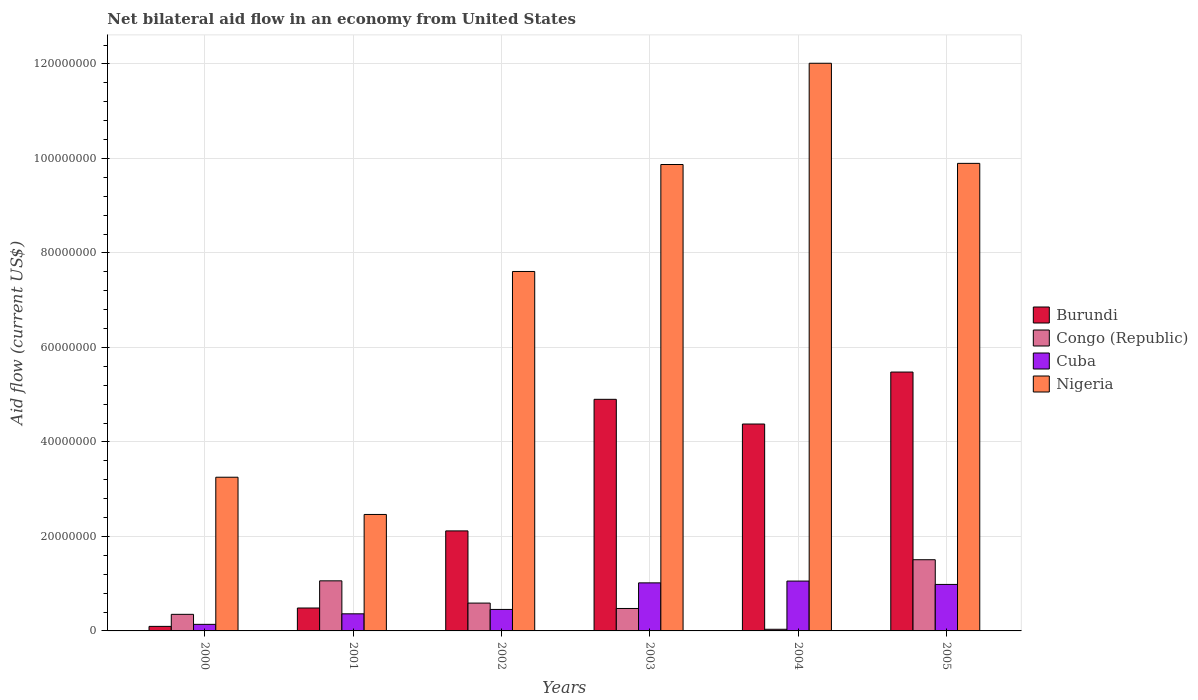Are the number of bars on each tick of the X-axis equal?
Your response must be concise. Yes. In how many cases, is the number of bars for a given year not equal to the number of legend labels?
Your answer should be compact. 0. What is the net bilateral aid flow in Congo (Republic) in 2003?
Ensure brevity in your answer.  4.75e+06. Across all years, what is the maximum net bilateral aid flow in Nigeria?
Give a very brief answer. 1.20e+08. In which year was the net bilateral aid flow in Nigeria maximum?
Provide a short and direct response. 2004. In which year was the net bilateral aid flow in Congo (Republic) minimum?
Offer a very short reply. 2004. What is the total net bilateral aid flow in Nigeria in the graph?
Your answer should be very brief. 4.51e+08. What is the difference between the net bilateral aid flow in Congo (Republic) in 2001 and that in 2004?
Ensure brevity in your answer.  1.02e+07. What is the difference between the net bilateral aid flow in Nigeria in 2000 and the net bilateral aid flow in Congo (Republic) in 2003?
Make the answer very short. 2.78e+07. What is the average net bilateral aid flow in Burundi per year?
Make the answer very short. 2.91e+07. In the year 2000, what is the difference between the net bilateral aid flow in Congo (Republic) and net bilateral aid flow in Nigeria?
Offer a very short reply. -2.90e+07. In how many years, is the net bilateral aid flow in Cuba greater than 8000000 US$?
Provide a succinct answer. 3. What is the ratio of the net bilateral aid flow in Burundi in 2000 to that in 2002?
Keep it short and to the point. 0.05. What is the difference between the highest and the second highest net bilateral aid flow in Cuba?
Give a very brief answer. 3.80e+05. What is the difference between the highest and the lowest net bilateral aid flow in Congo (Republic)?
Offer a terse response. 1.47e+07. Is it the case that in every year, the sum of the net bilateral aid flow in Cuba and net bilateral aid flow in Congo (Republic) is greater than the sum of net bilateral aid flow in Burundi and net bilateral aid flow in Nigeria?
Your response must be concise. No. What does the 3rd bar from the left in 2002 represents?
Ensure brevity in your answer.  Cuba. What does the 4th bar from the right in 2002 represents?
Ensure brevity in your answer.  Burundi. Is it the case that in every year, the sum of the net bilateral aid flow in Cuba and net bilateral aid flow in Congo (Republic) is greater than the net bilateral aid flow in Burundi?
Provide a short and direct response. No. Are all the bars in the graph horizontal?
Offer a very short reply. No. How many years are there in the graph?
Your response must be concise. 6. What is the difference between two consecutive major ticks on the Y-axis?
Offer a terse response. 2.00e+07. Are the values on the major ticks of Y-axis written in scientific E-notation?
Your answer should be compact. No. How are the legend labels stacked?
Provide a short and direct response. Vertical. What is the title of the graph?
Your answer should be compact. Net bilateral aid flow in an economy from United States. Does "Madagascar" appear as one of the legend labels in the graph?
Provide a succinct answer. No. What is the label or title of the X-axis?
Your answer should be very brief. Years. What is the label or title of the Y-axis?
Keep it short and to the point. Aid flow (current US$). What is the Aid flow (current US$) of Burundi in 2000?
Your answer should be compact. 9.60e+05. What is the Aid flow (current US$) of Congo (Republic) in 2000?
Offer a terse response. 3.51e+06. What is the Aid flow (current US$) of Cuba in 2000?
Give a very brief answer. 1.39e+06. What is the Aid flow (current US$) of Nigeria in 2000?
Offer a very short reply. 3.25e+07. What is the Aid flow (current US$) in Burundi in 2001?
Your response must be concise. 4.85e+06. What is the Aid flow (current US$) in Congo (Republic) in 2001?
Give a very brief answer. 1.06e+07. What is the Aid flow (current US$) in Cuba in 2001?
Offer a terse response. 3.62e+06. What is the Aid flow (current US$) in Nigeria in 2001?
Keep it short and to the point. 2.46e+07. What is the Aid flow (current US$) in Burundi in 2002?
Offer a very short reply. 2.12e+07. What is the Aid flow (current US$) in Congo (Republic) in 2002?
Provide a short and direct response. 5.89e+06. What is the Aid flow (current US$) in Cuba in 2002?
Your answer should be very brief. 4.55e+06. What is the Aid flow (current US$) in Nigeria in 2002?
Keep it short and to the point. 7.61e+07. What is the Aid flow (current US$) in Burundi in 2003?
Offer a very short reply. 4.90e+07. What is the Aid flow (current US$) in Congo (Republic) in 2003?
Your answer should be compact. 4.75e+06. What is the Aid flow (current US$) in Cuba in 2003?
Keep it short and to the point. 1.02e+07. What is the Aid flow (current US$) in Nigeria in 2003?
Provide a succinct answer. 9.87e+07. What is the Aid flow (current US$) in Burundi in 2004?
Offer a very short reply. 4.38e+07. What is the Aid flow (current US$) of Cuba in 2004?
Keep it short and to the point. 1.06e+07. What is the Aid flow (current US$) in Nigeria in 2004?
Your response must be concise. 1.20e+08. What is the Aid flow (current US$) of Burundi in 2005?
Give a very brief answer. 5.48e+07. What is the Aid flow (current US$) of Congo (Republic) in 2005?
Offer a terse response. 1.51e+07. What is the Aid flow (current US$) of Cuba in 2005?
Offer a very short reply. 9.84e+06. What is the Aid flow (current US$) in Nigeria in 2005?
Your answer should be very brief. 9.90e+07. Across all years, what is the maximum Aid flow (current US$) of Burundi?
Offer a very short reply. 5.48e+07. Across all years, what is the maximum Aid flow (current US$) of Congo (Republic)?
Give a very brief answer. 1.51e+07. Across all years, what is the maximum Aid flow (current US$) of Cuba?
Provide a short and direct response. 1.06e+07. Across all years, what is the maximum Aid flow (current US$) in Nigeria?
Make the answer very short. 1.20e+08. Across all years, what is the minimum Aid flow (current US$) in Burundi?
Offer a very short reply. 9.60e+05. Across all years, what is the minimum Aid flow (current US$) in Cuba?
Your response must be concise. 1.39e+06. Across all years, what is the minimum Aid flow (current US$) of Nigeria?
Provide a short and direct response. 2.46e+07. What is the total Aid flow (current US$) of Burundi in the graph?
Give a very brief answer. 1.75e+08. What is the total Aid flow (current US$) in Congo (Republic) in the graph?
Provide a short and direct response. 4.02e+07. What is the total Aid flow (current US$) in Cuba in the graph?
Your response must be concise. 4.01e+07. What is the total Aid flow (current US$) in Nigeria in the graph?
Provide a short and direct response. 4.51e+08. What is the difference between the Aid flow (current US$) of Burundi in 2000 and that in 2001?
Provide a short and direct response. -3.89e+06. What is the difference between the Aid flow (current US$) in Congo (Republic) in 2000 and that in 2001?
Give a very brief answer. -7.09e+06. What is the difference between the Aid flow (current US$) of Cuba in 2000 and that in 2001?
Provide a succinct answer. -2.23e+06. What is the difference between the Aid flow (current US$) of Nigeria in 2000 and that in 2001?
Make the answer very short. 7.88e+06. What is the difference between the Aid flow (current US$) in Burundi in 2000 and that in 2002?
Provide a succinct answer. -2.02e+07. What is the difference between the Aid flow (current US$) in Congo (Republic) in 2000 and that in 2002?
Your response must be concise. -2.38e+06. What is the difference between the Aid flow (current US$) of Cuba in 2000 and that in 2002?
Offer a terse response. -3.16e+06. What is the difference between the Aid flow (current US$) in Nigeria in 2000 and that in 2002?
Keep it short and to the point. -4.36e+07. What is the difference between the Aid flow (current US$) of Burundi in 2000 and that in 2003?
Provide a succinct answer. -4.81e+07. What is the difference between the Aid flow (current US$) of Congo (Republic) in 2000 and that in 2003?
Keep it short and to the point. -1.24e+06. What is the difference between the Aid flow (current US$) in Cuba in 2000 and that in 2003?
Ensure brevity in your answer.  -8.78e+06. What is the difference between the Aid flow (current US$) of Nigeria in 2000 and that in 2003?
Give a very brief answer. -6.62e+07. What is the difference between the Aid flow (current US$) in Burundi in 2000 and that in 2004?
Keep it short and to the point. -4.28e+07. What is the difference between the Aid flow (current US$) in Congo (Republic) in 2000 and that in 2004?
Your answer should be very brief. 3.16e+06. What is the difference between the Aid flow (current US$) in Cuba in 2000 and that in 2004?
Give a very brief answer. -9.16e+06. What is the difference between the Aid flow (current US$) of Nigeria in 2000 and that in 2004?
Make the answer very short. -8.76e+07. What is the difference between the Aid flow (current US$) in Burundi in 2000 and that in 2005?
Provide a succinct answer. -5.38e+07. What is the difference between the Aid flow (current US$) of Congo (Republic) in 2000 and that in 2005?
Your response must be concise. -1.16e+07. What is the difference between the Aid flow (current US$) in Cuba in 2000 and that in 2005?
Provide a succinct answer. -8.45e+06. What is the difference between the Aid flow (current US$) in Nigeria in 2000 and that in 2005?
Give a very brief answer. -6.64e+07. What is the difference between the Aid flow (current US$) of Burundi in 2001 and that in 2002?
Offer a terse response. -1.63e+07. What is the difference between the Aid flow (current US$) of Congo (Republic) in 2001 and that in 2002?
Give a very brief answer. 4.71e+06. What is the difference between the Aid flow (current US$) of Cuba in 2001 and that in 2002?
Your response must be concise. -9.30e+05. What is the difference between the Aid flow (current US$) in Nigeria in 2001 and that in 2002?
Offer a very short reply. -5.14e+07. What is the difference between the Aid flow (current US$) of Burundi in 2001 and that in 2003?
Give a very brief answer. -4.42e+07. What is the difference between the Aid flow (current US$) in Congo (Republic) in 2001 and that in 2003?
Your response must be concise. 5.85e+06. What is the difference between the Aid flow (current US$) of Cuba in 2001 and that in 2003?
Your answer should be very brief. -6.55e+06. What is the difference between the Aid flow (current US$) in Nigeria in 2001 and that in 2003?
Provide a short and direct response. -7.41e+07. What is the difference between the Aid flow (current US$) in Burundi in 2001 and that in 2004?
Give a very brief answer. -3.89e+07. What is the difference between the Aid flow (current US$) of Congo (Republic) in 2001 and that in 2004?
Make the answer very short. 1.02e+07. What is the difference between the Aid flow (current US$) in Cuba in 2001 and that in 2004?
Offer a very short reply. -6.93e+06. What is the difference between the Aid flow (current US$) of Nigeria in 2001 and that in 2004?
Give a very brief answer. -9.55e+07. What is the difference between the Aid flow (current US$) in Burundi in 2001 and that in 2005?
Your response must be concise. -4.99e+07. What is the difference between the Aid flow (current US$) in Congo (Republic) in 2001 and that in 2005?
Offer a terse response. -4.47e+06. What is the difference between the Aid flow (current US$) in Cuba in 2001 and that in 2005?
Provide a short and direct response. -6.22e+06. What is the difference between the Aid flow (current US$) in Nigeria in 2001 and that in 2005?
Keep it short and to the point. -7.43e+07. What is the difference between the Aid flow (current US$) of Burundi in 2002 and that in 2003?
Provide a short and direct response. -2.78e+07. What is the difference between the Aid flow (current US$) of Congo (Republic) in 2002 and that in 2003?
Your answer should be compact. 1.14e+06. What is the difference between the Aid flow (current US$) of Cuba in 2002 and that in 2003?
Keep it short and to the point. -5.62e+06. What is the difference between the Aid flow (current US$) of Nigeria in 2002 and that in 2003?
Make the answer very short. -2.26e+07. What is the difference between the Aid flow (current US$) of Burundi in 2002 and that in 2004?
Provide a succinct answer. -2.26e+07. What is the difference between the Aid flow (current US$) in Congo (Republic) in 2002 and that in 2004?
Provide a short and direct response. 5.54e+06. What is the difference between the Aid flow (current US$) in Cuba in 2002 and that in 2004?
Your answer should be very brief. -6.00e+06. What is the difference between the Aid flow (current US$) of Nigeria in 2002 and that in 2004?
Your response must be concise. -4.41e+07. What is the difference between the Aid flow (current US$) in Burundi in 2002 and that in 2005?
Provide a succinct answer. -3.36e+07. What is the difference between the Aid flow (current US$) of Congo (Republic) in 2002 and that in 2005?
Give a very brief answer. -9.18e+06. What is the difference between the Aid flow (current US$) of Cuba in 2002 and that in 2005?
Provide a short and direct response. -5.29e+06. What is the difference between the Aid flow (current US$) in Nigeria in 2002 and that in 2005?
Your answer should be compact. -2.29e+07. What is the difference between the Aid flow (current US$) of Burundi in 2003 and that in 2004?
Your response must be concise. 5.23e+06. What is the difference between the Aid flow (current US$) in Congo (Republic) in 2003 and that in 2004?
Keep it short and to the point. 4.40e+06. What is the difference between the Aid flow (current US$) in Cuba in 2003 and that in 2004?
Your answer should be compact. -3.80e+05. What is the difference between the Aid flow (current US$) of Nigeria in 2003 and that in 2004?
Keep it short and to the point. -2.14e+07. What is the difference between the Aid flow (current US$) in Burundi in 2003 and that in 2005?
Keep it short and to the point. -5.77e+06. What is the difference between the Aid flow (current US$) in Congo (Republic) in 2003 and that in 2005?
Your answer should be very brief. -1.03e+07. What is the difference between the Aid flow (current US$) in Nigeria in 2003 and that in 2005?
Offer a very short reply. -2.40e+05. What is the difference between the Aid flow (current US$) in Burundi in 2004 and that in 2005?
Give a very brief answer. -1.10e+07. What is the difference between the Aid flow (current US$) of Congo (Republic) in 2004 and that in 2005?
Your answer should be compact. -1.47e+07. What is the difference between the Aid flow (current US$) in Cuba in 2004 and that in 2005?
Offer a very short reply. 7.10e+05. What is the difference between the Aid flow (current US$) of Nigeria in 2004 and that in 2005?
Your answer should be compact. 2.12e+07. What is the difference between the Aid flow (current US$) of Burundi in 2000 and the Aid flow (current US$) of Congo (Republic) in 2001?
Offer a very short reply. -9.64e+06. What is the difference between the Aid flow (current US$) in Burundi in 2000 and the Aid flow (current US$) in Cuba in 2001?
Give a very brief answer. -2.66e+06. What is the difference between the Aid flow (current US$) of Burundi in 2000 and the Aid flow (current US$) of Nigeria in 2001?
Make the answer very short. -2.37e+07. What is the difference between the Aid flow (current US$) of Congo (Republic) in 2000 and the Aid flow (current US$) of Nigeria in 2001?
Make the answer very short. -2.11e+07. What is the difference between the Aid flow (current US$) of Cuba in 2000 and the Aid flow (current US$) of Nigeria in 2001?
Provide a succinct answer. -2.33e+07. What is the difference between the Aid flow (current US$) of Burundi in 2000 and the Aid flow (current US$) of Congo (Republic) in 2002?
Your answer should be very brief. -4.93e+06. What is the difference between the Aid flow (current US$) in Burundi in 2000 and the Aid flow (current US$) in Cuba in 2002?
Provide a short and direct response. -3.59e+06. What is the difference between the Aid flow (current US$) in Burundi in 2000 and the Aid flow (current US$) in Nigeria in 2002?
Give a very brief answer. -7.51e+07. What is the difference between the Aid flow (current US$) of Congo (Republic) in 2000 and the Aid flow (current US$) of Cuba in 2002?
Your response must be concise. -1.04e+06. What is the difference between the Aid flow (current US$) in Congo (Republic) in 2000 and the Aid flow (current US$) in Nigeria in 2002?
Make the answer very short. -7.26e+07. What is the difference between the Aid flow (current US$) in Cuba in 2000 and the Aid flow (current US$) in Nigeria in 2002?
Keep it short and to the point. -7.47e+07. What is the difference between the Aid flow (current US$) in Burundi in 2000 and the Aid flow (current US$) in Congo (Republic) in 2003?
Keep it short and to the point. -3.79e+06. What is the difference between the Aid flow (current US$) of Burundi in 2000 and the Aid flow (current US$) of Cuba in 2003?
Your answer should be compact. -9.21e+06. What is the difference between the Aid flow (current US$) of Burundi in 2000 and the Aid flow (current US$) of Nigeria in 2003?
Provide a short and direct response. -9.78e+07. What is the difference between the Aid flow (current US$) in Congo (Republic) in 2000 and the Aid flow (current US$) in Cuba in 2003?
Your answer should be very brief. -6.66e+06. What is the difference between the Aid flow (current US$) in Congo (Republic) in 2000 and the Aid flow (current US$) in Nigeria in 2003?
Your answer should be very brief. -9.52e+07. What is the difference between the Aid flow (current US$) in Cuba in 2000 and the Aid flow (current US$) in Nigeria in 2003?
Offer a terse response. -9.73e+07. What is the difference between the Aid flow (current US$) of Burundi in 2000 and the Aid flow (current US$) of Cuba in 2004?
Your response must be concise. -9.59e+06. What is the difference between the Aid flow (current US$) in Burundi in 2000 and the Aid flow (current US$) in Nigeria in 2004?
Your answer should be very brief. -1.19e+08. What is the difference between the Aid flow (current US$) in Congo (Republic) in 2000 and the Aid flow (current US$) in Cuba in 2004?
Your answer should be very brief. -7.04e+06. What is the difference between the Aid flow (current US$) of Congo (Republic) in 2000 and the Aid flow (current US$) of Nigeria in 2004?
Your answer should be compact. -1.17e+08. What is the difference between the Aid flow (current US$) of Cuba in 2000 and the Aid flow (current US$) of Nigeria in 2004?
Your response must be concise. -1.19e+08. What is the difference between the Aid flow (current US$) in Burundi in 2000 and the Aid flow (current US$) in Congo (Republic) in 2005?
Offer a terse response. -1.41e+07. What is the difference between the Aid flow (current US$) of Burundi in 2000 and the Aid flow (current US$) of Cuba in 2005?
Make the answer very short. -8.88e+06. What is the difference between the Aid flow (current US$) in Burundi in 2000 and the Aid flow (current US$) in Nigeria in 2005?
Make the answer very short. -9.80e+07. What is the difference between the Aid flow (current US$) in Congo (Republic) in 2000 and the Aid flow (current US$) in Cuba in 2005?
Offer a very short reply. -6.33e+06. What is the difference between the Aid flow (current US$) in Congo (Republic) in 2000 and the Aid flow (current US$) in Nigeria in 2005?
Offer a terse response. -9.54e+07. What is the difference between the Aid flow (current US$) of Cuba in 2000 and the Aid flow (current US$) of Nigeria in 2005?
Offer a terse response. -9.76e+07. What is the difference between the Aid flow (current US$) of Burundi in 2001 and the Aid flow (current US$) of Congo (Republic) in 2002?
Offer a terse response. -1.04e+06. What is the difference between the Aid flow (current US$) in Burundi in 2001 and the Aid flow (current US$) in Cuba in 2002?
Offer a very short reply. 3.00e+05. What is the difference between the Aid flow (current US$) in Burundi in 2001 and the Aid flow (current US$) in Nigeria in 2002?
Offer a very short reply. -7.12e+07. What is the difference between the Aid flow (current US$) in Congo (Republic) in 2001 and the Aid flow (current US$) in Cuba in 2002?
Provide a succinct answer. 6.05e+06. What is the difference between the Aid flow (current US$) of Congo (Republic) in 2001 and the Aid flow (current US$) of Nigeria in 2002?
Keep it short and to the point. -6.55e+07. What is the difference between the Aid flow (current US$) of Cuba in 2001 and the Aid flow (current US$) of Nigeria in 2002?
Offer a very short reply. -7.25e+07. What is the difference between the Aid flow (current US$) in Burundi in 2001 and the Aid flow (current US$) in Congo (Republic) in 2003?
Offer a very short reply. 1.00e+05. What is the difference between the Aid flow (current US$) of Burundi in 2001 and the Aid flow (current US$) of Cuba in 2003?
Give a very brief answer. -5.32e+06. What is the difference between the Aid flow (current US$) of Burundi in 2001 and the Aid flow (current US$) of Nigeria in 2003?
Offer a very short reply. -9.39e+07. What is the difference between the Aid flow (current US$) in Congo (Republic) in 2001 and the Aid flow (current US$) in Nigeria in 2003?
Keep it short and to the point. -8.81e+07. What is the difference between the Aid flow (current US$) of Cuba in 2001 and the Aid flow (current US$) of Nigeria in 2003?
Offer a terse response. -9.51e+07. What is the difference between the Aid flow (current US$) of Burundi in 2001 and the Aid flow (current US$) of Congo (Republic) in 2004?
Make the answer very short. 4.50e+06. What is the difference between the Aid flow (current US$) in Burundi in 2001 and the Aid flow (current US$) in Cuba in 2004?
Your response must be concise. -5.70e+06. What is the difference between the Aid flow (current US$) of Burundi in 2001 and the Aid flow (current US$) of Nigeria in 2004?
Provide a short and direct response. -1.15e+08. What is the difference between the Aid flow (current US$) in Congo (Republic) in 2001 and the Aid flow (current US$) in Cuba in 2004?
Offer a very short reply. 5.00e+04. What is the difference between the Aid flow (current US$) of Congo (Republic) in 2001 and the Aid flow (current US$) of Nigeria in 2004?
Provide a short and direct response. -1.10e+08. What is the difference between the Aid flow (current US$) in Cuba in 2001 and the Aid flow (current US$) in Nigeria in 2004?
Your answer should be compact. -1.17e+08. What is the difference between the Aid flow (current US$) of Burundi in 2001 and the Aid flow (current US$) of Congo (Republic) in 2005?
Provide a succinct answer. -1.02e+07. What is the difference between the Aid flow (current US$) in Burundi in 2001 and the Aid flow (current US$) in Cuba in 2005?
Offer a very short reply. -4.99e+06. What is the difference between the Aid flow (current US$) of Burundi in 2001 and the Aid flow (current US$) of Nigeria in 2005?
Provide a short and direct response. -9.41e+07. What is the difference between the Aid flow (current US$) in Congo (Republic) in 2001 and the Aid flow (current US$) in Cuba in 2005?
Your answer should be very brief. 7.60e+05. What is the difference between the Aid flow (current US$) in Congo (Republic) in 2001 and the Aid flow (current US$) in Nigeria in 2005?
Give a very brief answer. -8.84e+07. What is the difference between the Aid flow (current US$) in Cuba in 2001 and the Aid flow (current US$) in Nigeria in 2005?
Keep it short and to the point. -9.53e+07. What is the difference between the Aid flow (current US$) in Burundi in 2002 and the Aid flow (current US$) in Congo (Republic) in 2003?
Offer a very short reply. 1.64e+07. What is the difference between the Aid flow (current US$) in Burundi in 2002 and the Aid flow (current US$) in Cuba in 2003?
Keep it short and to the point. 1.10e+07. What is the difference between the Aid flow (current US$) of Burundi in 2002 and the Aid flow (current US$) of Nigeria in 2003?
Ensure brevity in your answer.  -7.76e+07. What is the difference between the Aid flow (current US$) in Congo (Republic) in 2002 and the Aid flow (current US$) in Cuba in 2003?
Keep it short and to the point. -4.28e+06. What is the difference between the Aid flow (current US$) of Congo (Republic) in 2002 and the Aid flow (current US$) of Nigeria in 2003?
Offer a terse response. -9.28e+07. What is the difference between the Aid flow (current US$) in Cuba in 2002 and the Aid flow (current US$) in Nigeria in 2003?
Provide a short and direct response. -9.42e+07. What is the difference between the Aid flow (current US$) in Burundi in 2002 and the Aid flow (current US$) in Congo (Republic) in 2004?
Offer a terse response. 2.08e+07. What is the difference between the Aid flow (current US$) in Burundi in 2002 and the Aid flow (current US$) in Cuba in 2004?
Provide a short and direct response. 1.06e+07. What is the difference between the Aid flow (current US$) in Burundi in 2002 and the Aid flow (current US$) in Nigeria in 2004?
Offer a very short reply. -9.90e+07. What is the difference between the Aid flow (current US$) of Congo (Republic) in 2002 and the Aid flow (current US$) of Cuba in 2004?
Your answer should be compact. -4.66e+06. What is the difference between the Aid flow (current US$) of Congo (Republic) in 2002 and the Aid flow (current US$) of Nigeria in 2004?
Provide a short and direct response. -1.14e+08. What is the difference between the Aid flow (current US$) in Cuba in 2002 and the Aid flow (current US$) in Nigeria in 2004?
Offer a terse response. -1.16e+08. What is the difference between the Aid flow (current US$) in Burundi in 2002 and the Aid flow (current US$) in Congo (Republic) in 2005?
Provide a short and direct response. 6.10e+06. What is the difference between the Aid flow (current US$) in Burundi in 2002 and the Aid flow (current US$) in Cuba in 2005?
Keep it short and to the point. 1.13e+07. What is the difference between the Aid flow (current US$) of Burundi in 2002 and the Aid flow (current US$) of Nigeria in 2005?
Your response must be concise. -7.78e+07. What is the difference between the Aid flow (current US$) of Congo (Republic) in 2002 and the Aid flow (current US$) of Cuba in 2005?
Make the answer very short. -3.95e+06. What is the difference between the Aid flow (current US$) in Congo (Republic) in 2002 and the Aid flow (current US$) in Nigeria in 2005?
Your answer should be very brief. -9.31e+07. What is the difference between the Aid flow (current US$) of Cuba in 2002 and the Aid flow (current US$) of Nigeria in 2005?
Give a very brief answer. -9.44e+07. What is the difference between the Aid flow (current US$) of Burundi in 2003 and the Aid flow (current US$) of Congo (Republic) in 2004?
Provide a succinct answer. 4.87e+07. What is the difference between the Aid flow (current US$) of Burundi in 2003 and the Aid flow (current US$) of Cuba in 2004?
Provide a succinct answer. 3.85e+07. What is the difference between the Aid flow (current US$) of Burundi in 2003 and the Aid flow (current US$) of Nigeria in 2004?
Give a very brief answer. -7.11e+07. What is the difference between the Aid flow (current US$) in Congo (Republic) in 2003 and the Aid flow (current US$) in Cuba in 2004?
Your response must be concise. -5.80e+06. What is the difference between the Aid flow (current US$) of Congo (Republic) in 2003 and the Aid flow (current US$) of Nigeria in 2004?
Your response must be concise. -1.15e+08. What is the difference between the Aid flow (current US$) in Cuba in 2003 and the Aid flow (current US$) in Nigeria in 2004?
Your response must be concise. -1.10e+08. What is the difference between the Aid flow (current US$) in Burundi in 2003 and the Aid flow (current US$) in Congo (Republic) in 2005?
Offer a very short reply. 3.40e+07. What is the difference between the Aid flow (current US$) of Burundi in 2003 and the Aid flow (current US$) of Cuba in 2005?
Provide a short and direct response. 3.92e+07. What is the difference between the Aid flow (current US$) in Burundi in 2003 and the Aid flow (current US$) in Nigeria in 2005?
Your response must be concise. -4.99e+07. What is the difference between the Aid flow (current US$) in Congo (Republic) in 2003 and the Aid flow (current US$) in Cuba in 2005?
Offer a very short reply. -5.09e+06. What is the difference between the Aid flow (current US$) of Congo (Republic) in 2003 and the Aid flow (current US$) of Nigeria in 2005?
Give a very brief answer. -9.42e+07. What is the difference between the Aid flow (current US$) in Cuba in 2003 and the Aid flow (current US$) in Nigeria in 2005?
Offer a terse response. -8.88e+07. What is the difference between the Aid flow (current US$) of Burundi in 2004 and the Aid flow (current US$) of Congo (Republic) in 2005?
Ensure brevity in your answer.  2.87e+07. What is the difference between the Aid flow (current US$) of Burundi in 2004 and the Aid flow (current US$) of Cuba in 2005?
Make the answer very short. 3.40e+07. What is the difference between the Aid flow (current US$) of Burundi in 2004 and the Aid flow (current US$) of Nigeria in 2005?
Ensure brevity in your answer.  -5.52e+07. What is the difference between the Aid flow (current US$) of Congo (Republic) in 2004 and the Aid flow (current US$) of Cuba in 2005?
Provide a succinct answer. -9.49e+06. What is the difference between the Aid flow (current US$) of Congo (Republic) in 2004 and the Aid flow (current US$) of Nigeria in 2005?
Offer a very short reply. -9.86e+07. What is the difference between the Aid flow (current US$) of Cuba in 2004 and the Aid flow (current US$) of Nigeria in 2005?
Keep it short and to the point. -8.84e+07. What is the average Aid flow (current US$) in Burundi per year?
Offer a terse response. 2.91e+07. What is the average Aid flow (current US$) in Congo (Republic) per year?
Offer a terse response. 6.70e+06. What is the average Aid flow (current US$) of Cuba per year?
Your response must be concise. 6.69e+06. What is the average Aid flow (current US$) in Nigeria per year?
Make the answer very short. 7.52e+07. In the year 2000, what is the difference between the Aid flow (current US$) in Burundi and Aid flow (current US$) in Congo (Republic)?
Make the answer very short. -2.55e+06. In the year 2000, what is the difference between the Aid flow (current US$) in Burundi and Aid flow (current US$) in Cuba?
Keep it short and to the point. -4.30e+05. In the year 2000, what is the difference between the Aid flow (current US$) of Burundi and Aid flow (current US$) of Nigeria?
Ensure brevity in your answer.  -3.16e+07. In the year 2000, what is the difference between the Aid flow (current US$) of Congo (Republic) and Aid flow (current US$) of Cuba?
Your response must be concise. 2.12e+06. In the year 2000, what is the difference between the Aid flow (current US$) of Congo (Republic) and Aid flow (current US$) of Nigeria?
Give a very brief answer. -2.90e+07. In the year 2000, what is the difference between the Aid flow (current US$) in Cuba and Aid flow (current US$) in Nigeria?
Provide a short and direct response. -3.11e+07. In the year 2001, what is the difference between the Aid flow (current US$) in Burundi and Aid flow (current US$) in Congo (Republic)?
Keep it short and to the point. -5.75e+06. In the year 2001, what is the difference between the Aid flow (current US$) of Burundi and Aid flow (current US$) of Cuba?
Give a very brief answer. 1.23e+06. In the year 2001, what is the difference between the Aid flow (current US$) of Burundi and Aid flow (current US$) of Nigeria?
Your response must be concise. -1.98e+07. In the year 2001, what is the difference between the Aid flow (current US$) in Congo (Republic) and Aid flow (current US$) in Cuba?
Your response must be concise. 6.98e+06. In the year 2001, what is the difference between the Aid flow (current US$) in Congo (Republic) and Aid flow (current US$) in Nigeria?
Provide a short and direct response. -1.40e+07. In the year 2001, what is the difference between the Aid flow (current US$) in Cuba and Aid flow (current US$) in Nigeria?
Offer a very short reply. -2.10e+07. In the year 2002, what is the difference between the Aid flow (current US$) in Burundi and Aid flow (current US$) in Congo (Republic)?
Ensure brevity in your answer.  1.53e+07. In the year 2002, what is the difference between the Aid flow (current US$) in Burundi and Aid flow (current US$) in Cuba?
Offer a terse response. 1.66e+07. In the year 2002, what is the difference between the Aid flow (current US$) of Burundi and Aid flow (current US$) of Nigeria?
Make the answer very short. -5.49e+07. In the year 2002, what is the difference between the Aid flow (current US$) in Congo (Republic) and Aid flow (current US$) in Cuba?
Make the answer very short. 1.34e+06. In the year 2002, what is the difference between the Aid flow (current US$) of Congo (Republic) and Aid flow (current US$) of Nigeria?
Ensure brevity in your answer.  -7.02e+07. In the year 2002, what is the difference between the Aid flow (current US$) in Cuba and Aid flow (current US$) in Nigeria?
Offer a very short reply. -7.15e+07. In the year 2003, what is the difference between the Aid flow (current US$) in Burundi and Aid flow (current US$) in Congo (Republic)?
Give a very brief answer. 4.43e+07. In the year 2003, what is the difference between the Aid flow (current US$) in Burundi and Aid flow (current US$) in Cuba?
Provide a succinct answer. 3.88e+07. In the year 2003, what is the difference between the Aid flow (current US$) in Burundi and Aid flow (current US$) in Nigeria?
Keep it short and to the point. -4.97e+07. In the year 2003, what is the difference between the Aid flow (current US$) in Congo (Republic) and Aid flow (current US$) in Cuba?
Make the answer very short. -5.42e+06. In the year 2003, what is the difference between the Aid flow (current US$) of Congo (Republic) and Aid flow (current US$) of Nigeria?
Make the answer very short. -9.40e+07. In the year 2003, what is the difference between the Aid flow (current US$) in Cuba and Aid flow (current US$) in Nigeria?
Your answer should be compact. -8.86e+07. In the year 2004, what is the difference between the Aid flow (current US$) in Burundi and Aid flow (current US$) in Congo (Republic)?
Keep it short and to the point. 4.34e+07. In the year 2004, what is the difference between the Aid flow (current US$) of Burundi and Aid flow (current US$) of Cuba?
Ensure brevity in your answer.  3.32e+07. In the year 2004, what is the difference between the Aid flow (current US$) of Burundi and Aid flow (current US$) of Nigeria?
Provide a short and direct response. -7.64e+07. In the year 2004, what is the difference between the Aid flow (current US$) in Congo (Republic) and Aid flow (current US$) in Cuba?
Provide a short and direct response. -1.02e+07. In the year 2004, what is the difference between the Aid flow (current US$) in Congo (Republic) and Aid flow (current US$) in Nigeria?
Your answer should be compact. -1.20e+08. In the year 2004, what is the difference between the Aid flow (current US$) in Cuba and Aid flow (current US$) in Nigeria?
Ensure brevity in your answer.  -1.10e+08. In the year 2005, what is the difference between the Aid flow (current US$) in Burundi and Aid flow (current US$) in Congo (Republic)?
Your answer should be very brief. 3.97e+07. In the year 2005, what is the difference between the Aid flow (current US$) in Burundi and Aid flow (current US$) in Cuba?
Your answer should be compact. 4.50e+07. In the year 2005, what is the difference between the Aid flow (current US$) in Burundi and Aid flow (current US$) in Nigeria?
Your answer should be compact. -4.42e+07. In the year 2005, what is the difference between the Aid flow (current US$) of Congo (Republic) and Aid flow (current US$) of Cuba?
Provide a succinct answer. 5.23e+06. In the year 2005, what is the difference between the Aid flow (current US$) of Congo (Republic) and Aid flow (current US$) of Nigeria?
Keep it short and to the point. -8.39e+07. In the year 2005, what is the difference between the Aid flow (current US$) of Cuba and Aid flow (current US$) of Nigeria?
Make the answer very short. -8.91e+07. What is the ratio of the Aid flow (current US$) of Burundi in 2000 to that in 2001?
Ensure brevity in your answer.  0.2. What is the ratio of the Aid flow (current US$) of Congo (Republic) in 2000 to that in 2001?
Offer a terse response. 0.33. What is the ratio of the Aid flow (current US$) in Cuba in 2000 to that in 2001?
Provide a short and direct response. 0.38. What is the ratio of the Aid flow (current US$) of Nigeria in 2000 to that in 2001?
Offer a very short reply. 1.32. What is the ratio of the Aid flow (current US$) of Burundi in 2000 to that in 2002?
Offer a very short reply. 0.05. What is the ratio of the Aid flow (current US$) in Congo (Republic) in 2000 to that in 2002?
Provide a succinct answer. 0.6. What is the ratio of the Aid flow (current US$) of Cuba in 2000 to that in 2002?
Your answer should be compact. 0.31. What is the ratio of the Aid flow (current US$) of Nigeria in 2000 to that in 2002?
Offer a very short reply. 0.43. What is the ratio of the Aid flow (current US$) in Burundi in 2000 to that in 2003?
Your answer should be very brief. 0.02. What is the ratio of the Aid flow (current US$) in Congo (Republic) in 2000 to that in 2003?
Ensure brevity in your answer.  0.74. What is the ratio of the Aid flow (current US$) in Cuba in 2000 to that in 2003?
Offer a terse response. 0.14. What is the ratio of the Aid flow (current US$) in Nigeria in 2000 to that in 2003?
Your response must be concise. 0.33. What is the ratio of the Aid flow (current US$) of Burundi in 2000 to that in 2004?
Your answer should be very brief. 0.02. What is the ratio of the Aid flow (current US$) in Congo (Republic) in 2000 to that in 2004?
Offer a terse response. 10.03. What is the ratio of the Aid flow (current US$) of Cuba in 2000 to that in 2004?
Ensure brevity in your answer.  0.13. What is the ratio of the Aid flow (current US$) in Nigeria in 2000 to that in 2004?
Offer a terse response. 0.27. What is the ratio of the Aid flow (current US$) in Burundi in 2000 to that in 2005?
Your answer should be very brief. 0.02. What is the ratio of the Aid flow (current US$) in Congo (Republic) in 2000 to that in 2005?
Make the answer very short. 0.23. What is the ratio of the Aid flow (current US$) in Cuba in 2000 to that in 2005?
Your response must be concise. 0.14. What is the ratio of the Aid flow (current US$) of Nigeria in 2000 to that in 2005?
Provide a short and direct response. 0.33. What is the ratio of the Aid flow (current US$) in Burundi in 2001 to that in 2002?
Offer a terse response. 0.23. What is the ratio of the Aid flow (current US$) in Congo (Republic) in 2001 to that in 2002?
Your answer should be very brief. 1.8. What is the ratio of the Aid flow (current US$) of Cuba in 2001 to that in 2002?
Offer a very short reply. 0.8. What is the ratio of the Aid flow (current US$) of Nigeria in 2001 to that in 2002?
Provide a succinct answer. 0.32. What is the ratio of the Aid flow (current US$) of Burundi in 2001 to that in 2003?
Provide a succinct answer. 0.1. What is the ratio of the Aid flow (current US$) in Congo (Republic) in 2001 to that in 2003?
Give a very brief answer. 2.23. What is the ratio of the Aid flow (current US$) of Cuba in 2001 to that in 2003?
Offer a terse response. 0.36. What is the ratio of the Aid flow (current US$) of Nigeria in 2001 to that in 2003?
Your answer should be very brief. 0.25. What is the ratio of the Aid flow (current US$) in Burundi in 2001 to that in 2004?
Ensure brevity in your answer.  0.11. What is the ratio of the Aid flow (current US$) in Congo (Republic) in 2001 to that in 2004?
Keep it short and to the point. 30.29. What is the ratio of the Aid flow (current US$) of Cuba in 2001 to that in 2004?
Offer a terse response. 0.34. What is the ratio of the Aid flow (current US$) of Nigeria in 2001 to that in 2004?
Ensure brevity in your answer.  0.21. What is the ratio of the Aid flow (current US$) of Burundi in 2001 to that in 2005?
Keep it short and to the point. 0.09. What is the ratio of the Aid flow (current US$) of Congo (Republic) in 2001 to that in 2005?
Make the answer very short. 0.7. What is the ratio of the Aid flow (current US$) of Cuba in 2001 to that in 2005?
Provide a succinct answer. 0.37. What is the ratio of the Aid flow (current US$) in Nigeria in 2001 to that in 2005?
Provide a succinct answer. 0.25. What is the ratio of the Aid flow (current US$) of Burundi in 2002 to that in 2003?
Provide a short and direct response. 0.43. What is the ratio of the Aid flow (current US$) in Congo (Republic) in 2002 to that in 2003?
Ensure brevity in your answer.  1.24. What is the ratio of the Aid flow (current US$) in Cuba in 2002 to that in 2003?
Make the answer very short. 0.45. What is the ratio of the Aid flow (current US$) in Nigeria in 2002 to that in 2003?
Offer a very short reply. 0.77. What is the ratio of the Aid flow (current US$) in Burundi in 2002 to that in 2004?
Ensure brevity in your answer.  0.48. What is the ratio of the Aid flow (current US$) of Congo (Republic) in 2002 to that in 2004?
Offer a very short reply. 16.83. What is the ratio of the Aid flow (current US$) in Cuba in 2002 to that in 2004?
Your response must be concise. 0.43. What is the ratio of the Aid flow (current US$) in Nigeria in 2002 to that in 2004?
Provide a short and direct response. 0.63. What is the ratio of the Aid flow (current US$) in Burundi in 2002 to that in 2005?
Make the answer very short. 0.39. What is the ratio of the Aid flow (current US$) in Congo (Republic) in 2002 to that in 2005?
Your answer should be compact. 0.39. What is the ratio of the Aid flow (current US$) in Cuba in 2002 to that in 2005?
Your answer should be compact. 0.46. What is the ratio of the Aid flow (current US$) of Nigeria in 2002 to that in 2005?
Give a very brief answer. 0.77. What is the ratio of the Aid flow (current US$) in Burundi in 2003 to that in 2004?
Give a very brief answer. 1.12. What is the ratio of the Aid flow (current US$) of Congo (Republic) in 2003 to that in 2004?
Provide a succinct answer. 13.57. What is the ratio of the Aid flow (current US$) in Cuba in 2003 to that in 2004?
Ensure brevity in your answer.  0.96. What is the ratio of the Aid flow (current US$) in Nigeria in 2003 to that in 2004?
Make the answer very short. 0.82. What is the ratio of the Aid flow (current US$) in Burundi in 2003 to that in 2005?
Offer a terse response. 0.89. What is the ratio of the Aid flow (current US$) of Congo (Republic) in 2003 to that in 2005?
Offer a very short reply. 0.32. What is the ratio of the Aid flow (current US$) in Cuba in 2003 to that in 2005?
Ensure brevity in your answer.  1.03. What is the ratio of the Aid flow (current US$) of Nigeria in 2003 to that in 2005?
Ensure brevity in your answer.  1. What is the ratio of the Aid flow (current US$) of Burundi in 2004 to that in 2005?
Provide a succinct answer. 0.8. What is the ratio of the Aid flow (current US$) of Congo (Republic) in 2004 to that in 2005?
Offer a terse response. 0.02. What is the ratio of the Aid flow (current US$) in Cuba in 2004 to that in 2005?
Give a very brief answer. 1.07. What is the ratio of the Aid flow (current US$) of Nigeria in 2004 to that in 2005?
Provide a succinct answer. 1.21. What is the difference between the highest and the second highest Aid flow (current US$) in Burundi?
Your answer should be very brief. 5.77e+06. What is the difference between the highest and the second highest Aid flow (current US$) in Congo (Republic)?
Give a very brief answer. 4.47e+06. What is the difference between the highest and the second highest Aid flow (current US$) in Nigeria?
Your answer should be very brief. 2.12e+07. What is the difference between the highest and the lowest Aid flow (current US$) of Burundi?
Your response must be concise. 5.38e+07. What is the difference between the highest and the lowest Aid flow (current US$) of Congo (Republic)?
Provide a succinct answer. 1.47e+07. What is the difference between the highest and the lowest Aid flow (current US$) in Cuba?
Provide a succinct answer. 9.16e+06. What is the difference between the highest and the lowest Aid flow (current US$) in Nigeria?
Keep it short and to the point. 9.55e+07. 